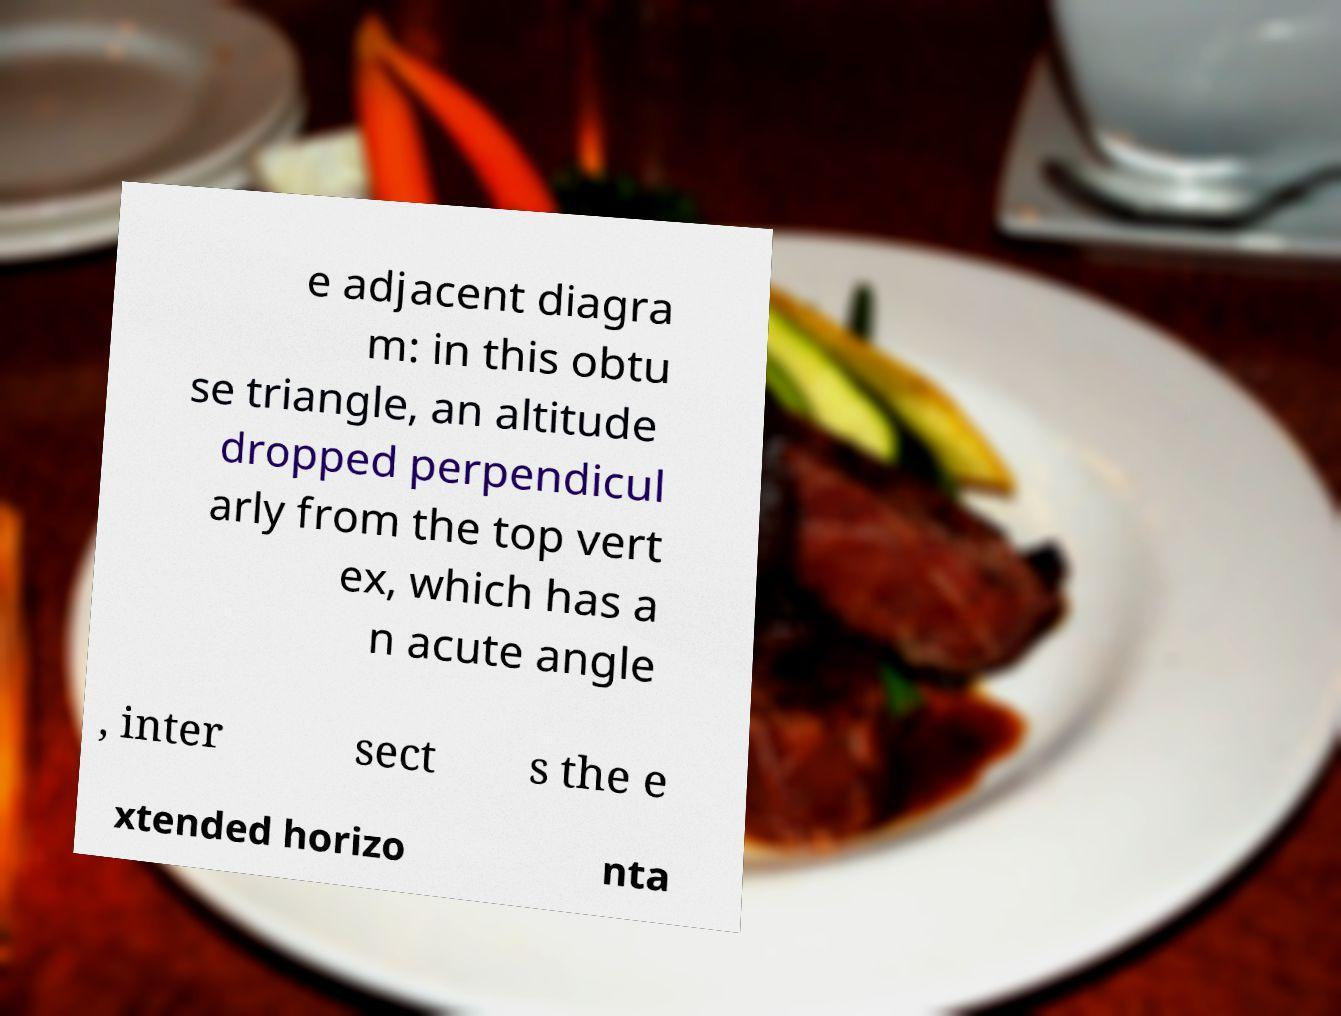Could you extract and type out the text from this image? e adjacent diagra m: in this obtu se triangle, an altitude dropped perpendicul arly from the top vert ex, which has a n acute angle , inter sect s the e xtended horizo nta 